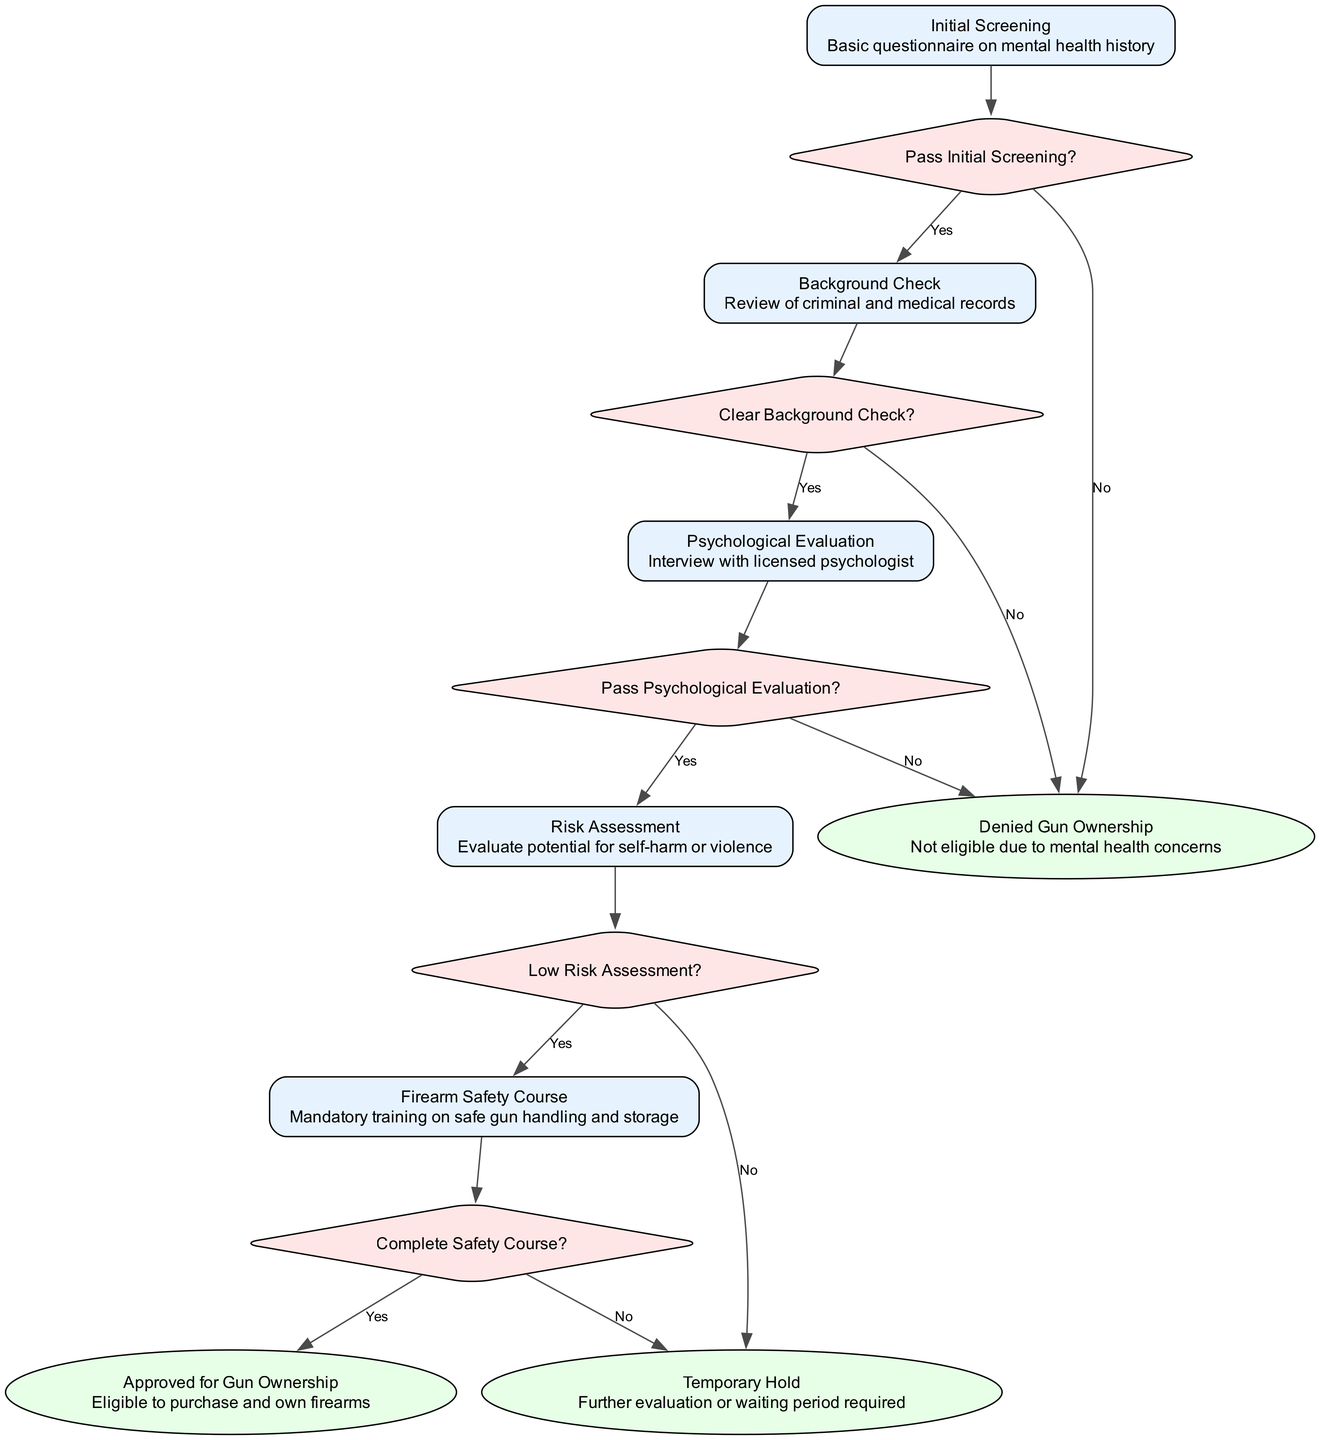What is the first step in the pathway? The first step in the clinical pathway is "Initial Screening," which is indicated by the first node in the diagram.
Answer: Initial Screening How many steps are there in total? The diagram lists 5 distinct steps in the clinical pathway, each with its own identifier and description.
Answer: 5 What happens if a person does not pass the initial screening? If a person does not pass the initial screening, the pathway indicates they will lead to "Denied Gun Ownership," which is an outcome connected to the initial screening decision.
Answer: Denied Gun Ownership What is required after a clear background check? Following a clear background check, the next step in the pathway is a "Psychological Evaluation," which is connected to the decision node that follows the background check step.
Answer: Psychological Evaluation What are the options available after the Risk Assessment? The decision made after the Risk Assessment has two options: "Yes" for low risk, leading to the Firearm Safety Course, and "No," which leads to a "Temporary Hold."
Answer: Yes, No What type of evaluation occurs in step three? In step three, the evaluation is a "Psychological Evaluation," which involves an interview with a licensed psychologist as described in the node for that step.
Answer: Psychological Evaluation What is indicated by the outcome "Temporary Hold"? The outcome "Temporary Hold" indicates that further evaluation or a waiting period is required, which is a specific response to the decision made after the Risk Assessment step.
Answer: Temporary Hold What is the final outcome if the safety course is completed? If the safety course is completed, the final outcome will be "Approved for Gun Ownership," which is the positive result expected when all prior steps are successfully met.
Answer: Approved for Gun Ownership What does the decision "Clear Background Check?" lead to if answered "No"? If the decision "Clear Background Check?" is answered "No," it leads directly to the outcome of "Denied Gun Ownership," signaling ineligibility due to background issues.
Answer: Denied Gun Ownership 